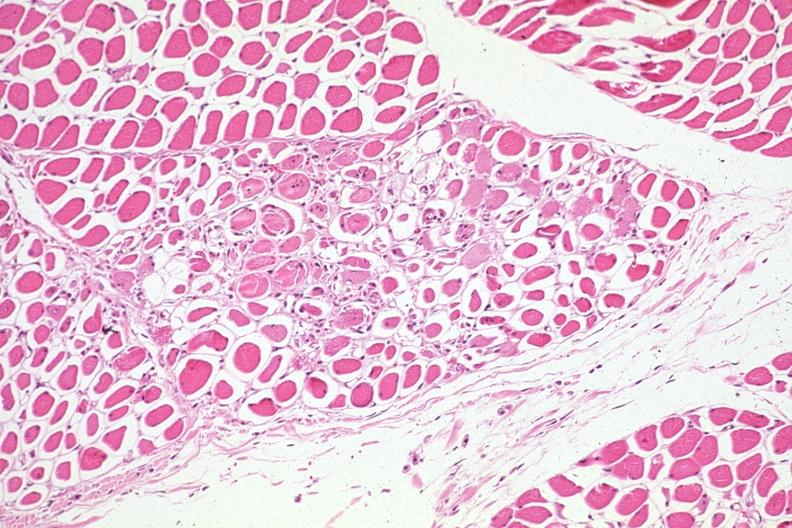what is present?
Answer the question using a single word or phrase. Muscle 